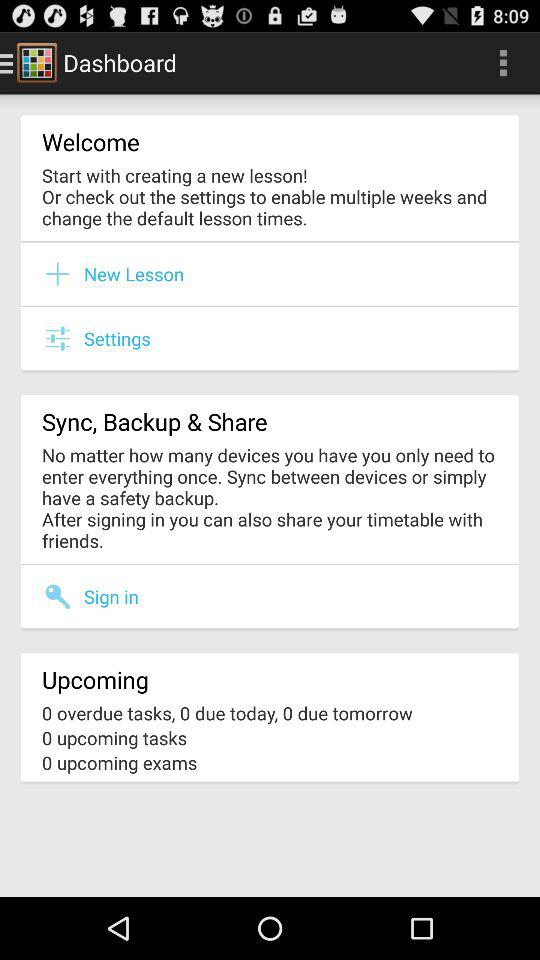How many tasks are due tomorrow?
Answer the question using a single word or phrase. 0 